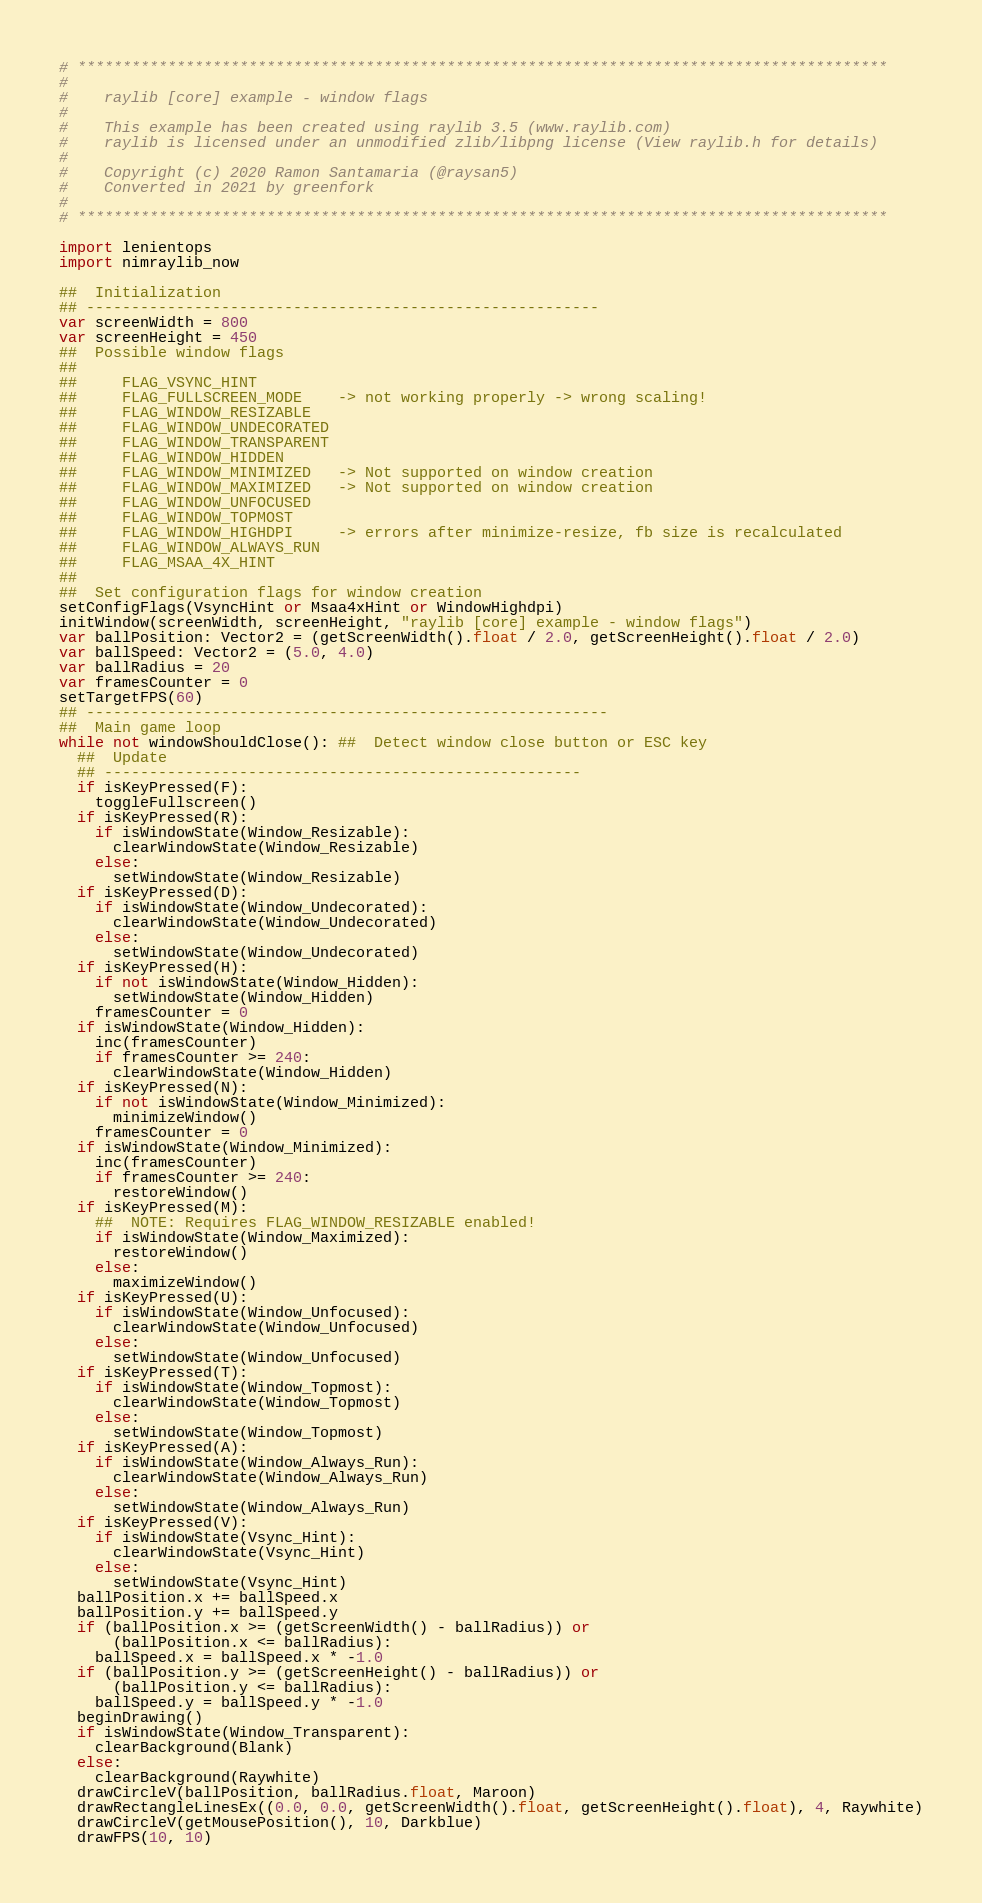<code> <loc_0><loc_0><loc_500><loc_500><_Nim_># ******************************************************************************************
#
#    raylib [core] example - window flags
#
#    This example has been created using raylib 3.5 (www.raylib.com)
#    raylib is licensed under an unmodified zlib/libpng license (View raylib.h for details)
#
#    Copyright (c) 2020 Ramon Santamaria (@raysan5)
#    Converted in 2021 by greenfork
#
# ******************************************************************************************

import lenientops
import nimraylib_now

##  Initialization
## ---------------------------------------------------------
var screenWidth = 800
var screenHeight = 450
##  Possible window flags
##
##     FLAG_VSYNC_HINT
##     FLAG_FULLSCREEN_MODE    -> not working properly -> wrong scaling!
##     FLAG_WINDOW_RESIZABLE
##     FLAG_WINDOW_UNDECORATED
##     FLAG_WINDOW_TRANSPARENT
##     FLAG_WINDOW_HIDDEN
##     FLAG_WINDOW_MINIMIZED   -> Not supported on window creation
##     FLAG_WINDOW_MAXIMIZED   -> Not supported on window creation
##     FLAG_WINDOW_UNFOCUSED
##     FLAG_WINDOW_TOPMOST
##     FLAG_WINDOW_HIGHDPI     -> errors after minimize-resize, fb size is recalculated
##     FLAG_WINDOW_ALWAYS_RUN
##     FLAG_MSAA_4X_HINT
##
##  Set configuration flags for window creation
setConfigFlags(VsyncHint or Msaa4xHint or WindowHighdpi)
initWindow(screenWidth, screenHeight, "raylib [core] example - window flags")
var ballPosition: Vector2 = (getScreenWidth().float / 2.0, getScreenHeight().float / 2.0)
var ballSpeed: Vector2 = (5.0, 4.0)
var ballRadius = 20
var framesCounter = 0
setTargetFPS(60)
## ----------------------------------------------------------
##  Main game loop
while not windowShouldClose(): ##  Detect window close button or ESC key
  ##  Update
  ## -----------------------------------------------------
  if isKeyPressed(F):
    toggleFullscreen()
  if isKeyPressed(R):
    if isWindowState(Window_Resizable):
      clearWindowState(Window_Resizable)
    else:
      setWindowState(Window_Resizable)
  if isKeyPressed(D):
    if isWindowState(Window_Undecorated):
      clearWindowState(Window_Undecorated)
    else:
      setWindowState(Window_Undecorated)
  if isKeyPressed(H):
    if not isWindowState(Window_Hidden):
      setWindowState(Window_Hidden)
    framesCounter = 0
  if isWindowState(Window_Hidden):
    inc(framesCounter)
    if framesCounter >= 240:
      clearWindowState(Window_Hidden)
  if isKeyPressed(N):
    if not isWindowState(Window_Minimized):
      minimizeWindow()
    framesCounter = 0
  if isWindowState(Window_Minimized):
    inc(framesCounter)
    if framesCounter >= 240:
      restoreWindow()
  if isKeyPressed(M):
    ##  NOTE: Requires FLAG_WINDOW_RESIZABLE enabled!
    if isWindowState(Window_Maximized):
      restoreWindow()
    else:
      maximizeWindow()
  if isKeyPressed(U):
    if isWindowState(Window_Unfocused):
      clearWindowState(Window_Unfocused)
    else:
      setWindowState(Window_Unfocused)
  if isKeyPressed(T):
    if isWindowState(Window_Topmost):
      clearWindowState(Window_Topmost)
    else:
      setWindowState(Window_Topmost)
  if isKeyPressed(A):
    if isWindowState(Window_Always_Run):
      clearWindowState(Window_Always_Run)
    else:
      setWindowState(Window_Always_Run)
  if isKeyPressed(V):
    if isWindowState(Vsync_Hint):
      clearWindowState(Vsync_Hint)
    else:
      setWindowState(Vsync_Hint)
  ballPosition.x += ballSpeed.x
  ballPosition.y += ballSpeed.y
  if (ballPosition.x >= (getScreenWidth() - ballRadius)) or
      (ballPosition.x <= ballRadius):
    ballSpeed.x = ballSpeed.x * -1.0
  if (ballPosition.y >= (getScreenHeight() - ballRadius)) or
      (ballPosition.y <= ballRadius):
    ballSpeed.y = ballSpeed.y * -1.0
  beginDrawing()
  if isWindowState(Window_Transparent):
    clearBackground(Blank)
  else:
    clearBackground(Raywhite)
  drawCircleV(ballPosition, ballRadius.float, Maroon)
  drawRectangleLinesEx((0.0, 0.0, getScreenWidth().float, getScreenHeight().float), 4, Raywhite)
  drawCircleV(getMousePosition(), 10, Darkblue)
  drawFPS(10, 10)</code> 